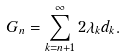<formula> <loc_0><loc_0><loc_500><loc_500>G _ { n } = \sum _ { k = { n + 1 } } ^ { \infty } 2 \lambda _ { k } d _ { k } .</formula> 